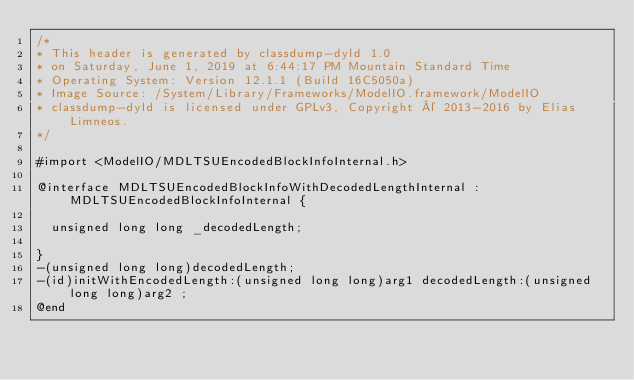Convert code to text. <code><loc_0><loc_0><loc_500><loc_500><_C_>/*
* This header is generated by classdump-dyld 1.0
* on Saturday, June 1, 2019 at 6:44:17 PM Mountain Standard Time
* Operating System: Version 12.1.1 (Build 16C5050a)
* Image Source: /System/Library/Frameworks/ModelIO.framework/ModelIO
* classdump-dyld is licensed under GPLv3, Copyright © 2013-2016 by Elias Limneos.
*/

#import <ModelIO/MDLTSUEncodedBlockInfoInternal.h>

@interface MDLTSUEncodedBlockInfoWithDecodedLengthInternal : MDLTSUEncodedBlockInfoInternal {

	unsigned long long _decodedLength;

}
-(unsigned long long)decodedLength;
-(id)initWithEncodedLength:(unsigned long long)arg1 decodedLength:(unsigned long long)arg2 ;
@end

</code> 